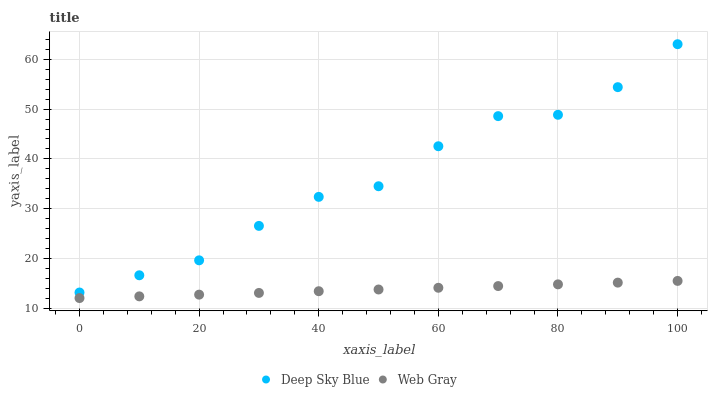Does Web Gray have the minimum area under the curve?
Answer yes or no. Yes. Does Deep Sky Blue have the maximum area under the curve?
Answer yes or no. Yes. Does Deep Sky Blue have the minimum area under the curve?
Answer yes or no. No. Is Web Gray the smoothest?
Answer yes or no. Yes. Is Deep Sky Blue the roughest?
Answer yes or no. Yes. Is Deep Sky Blue the smoothest?
Answer yes or no. No. Does Web Gray have the lowest value?
Answer yes or no. Yes. Does Deep Sky Blue have the lowest value?
Answer yes or no. No. Does Deep Sky Blue have the highest value?
Answer yes or no. Yes. Is Web Gray less than Deep Sky Blue?
Answer yes or no. Yes. Is Deep Sky Blue greater than Web Gray?
Answer yes or no. Yes. Does Web Gray intersect Deep Sky Blue?
Answer yes or no. No. 